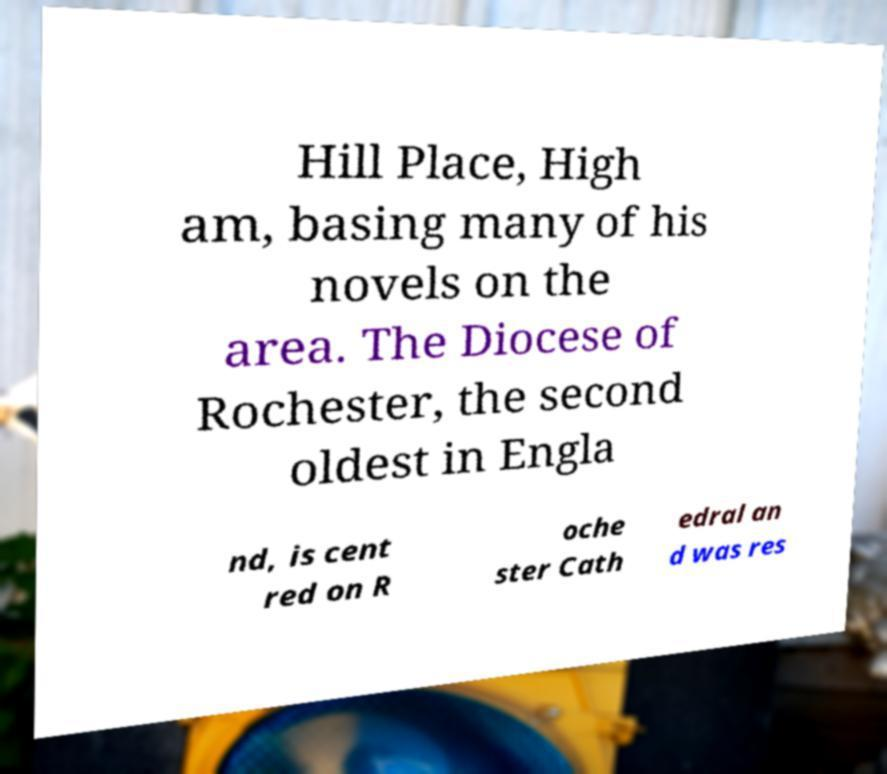Could you extract and type out the text from this image? Hill Place, High am, basing many of his novels on the area. The Diocese of Rochester, the second oldest in Engla nd, is cent red on R oche ster Cath edral an d was res 